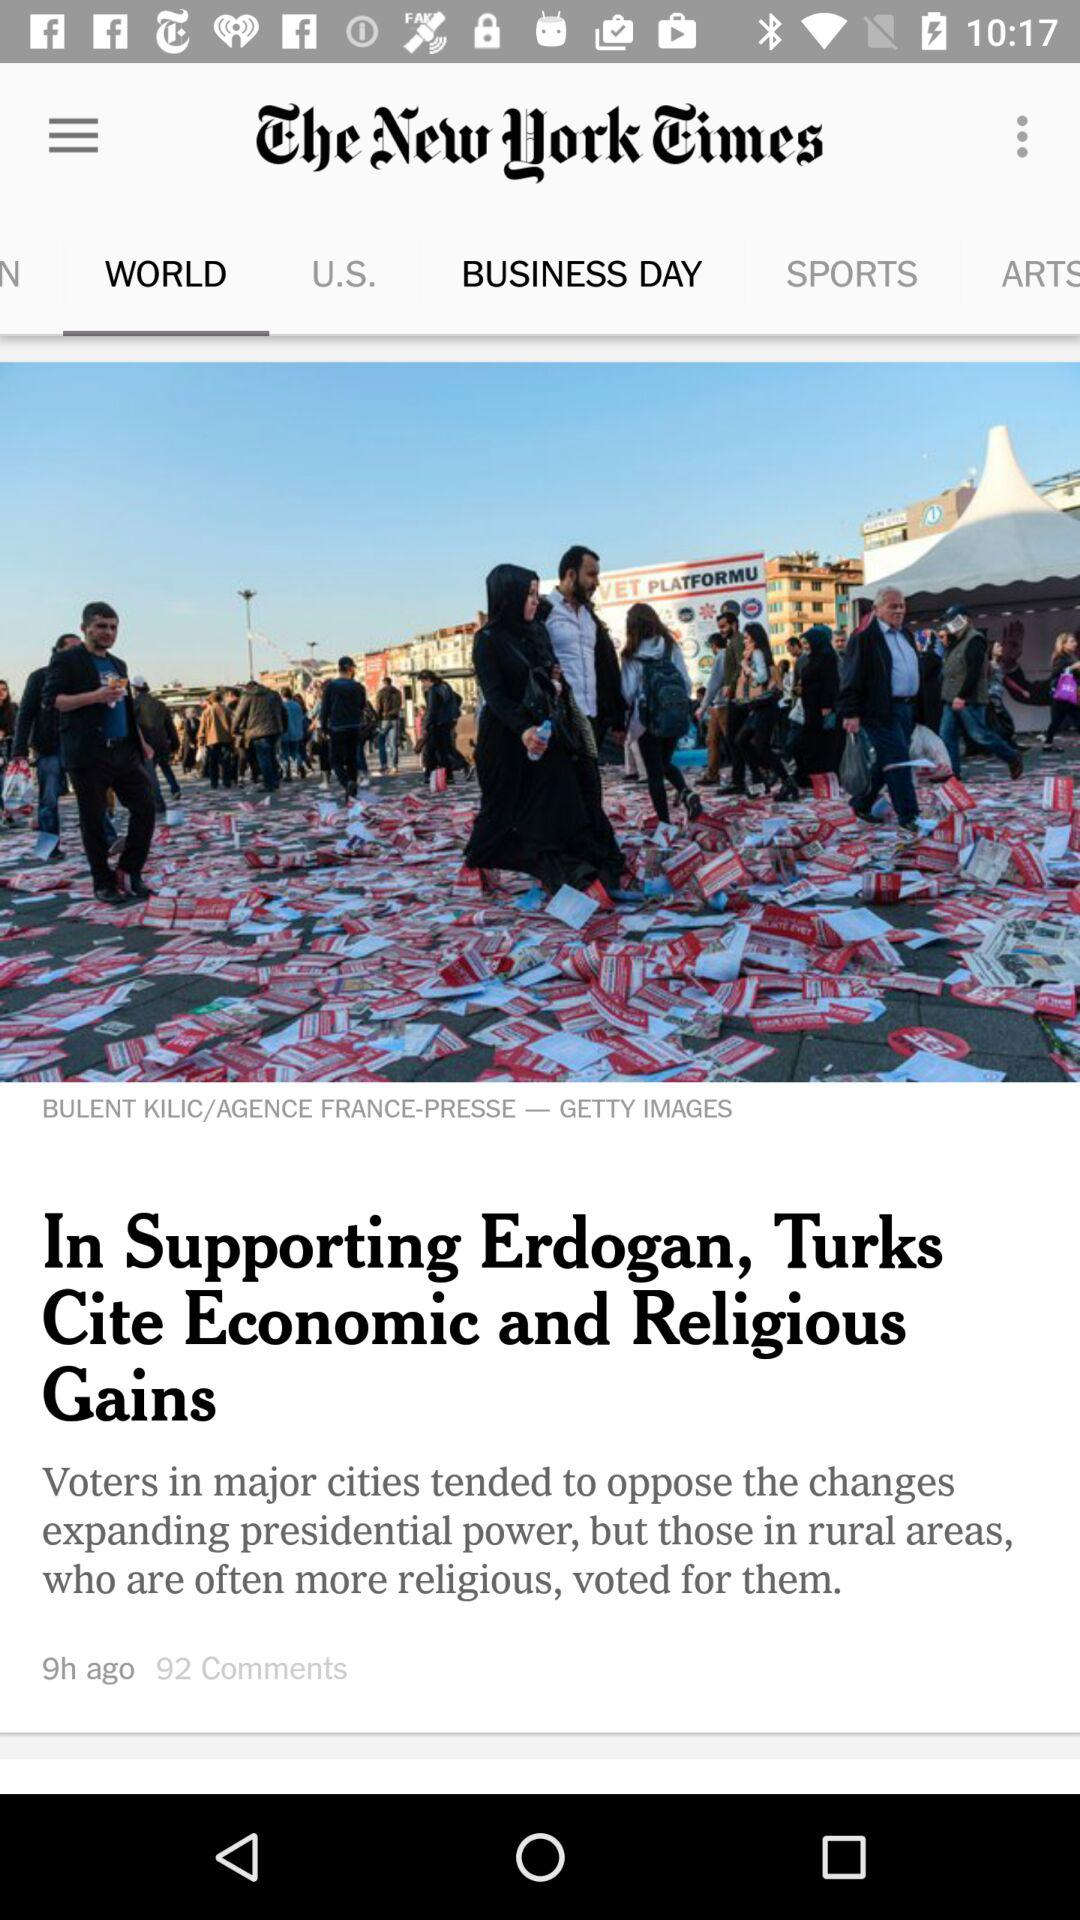When was the article posted? The article was posted 9 hours ago. 